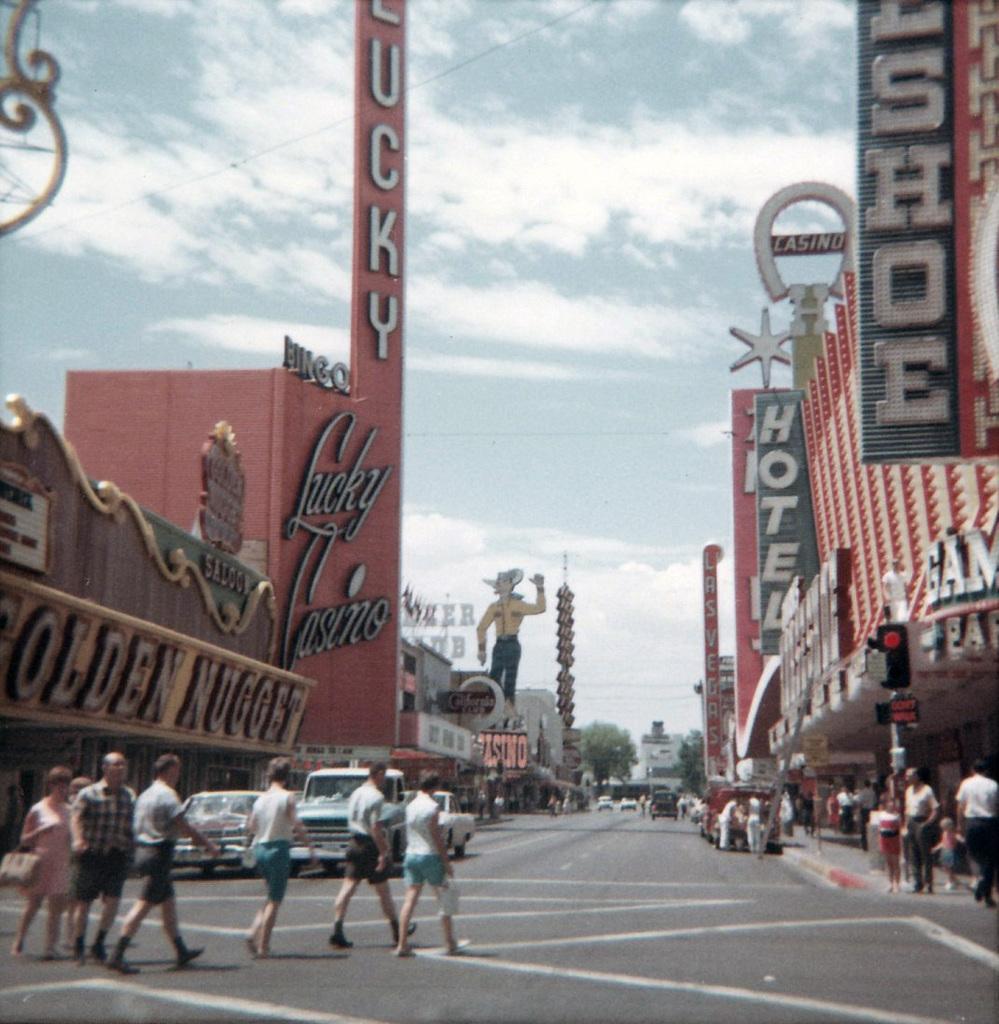Describe this image in one or two sentences. In this picture there are buildings with some text on left and right corner. There are people,cars in the foreground. The road is at the bottom and The sky is at the top. 